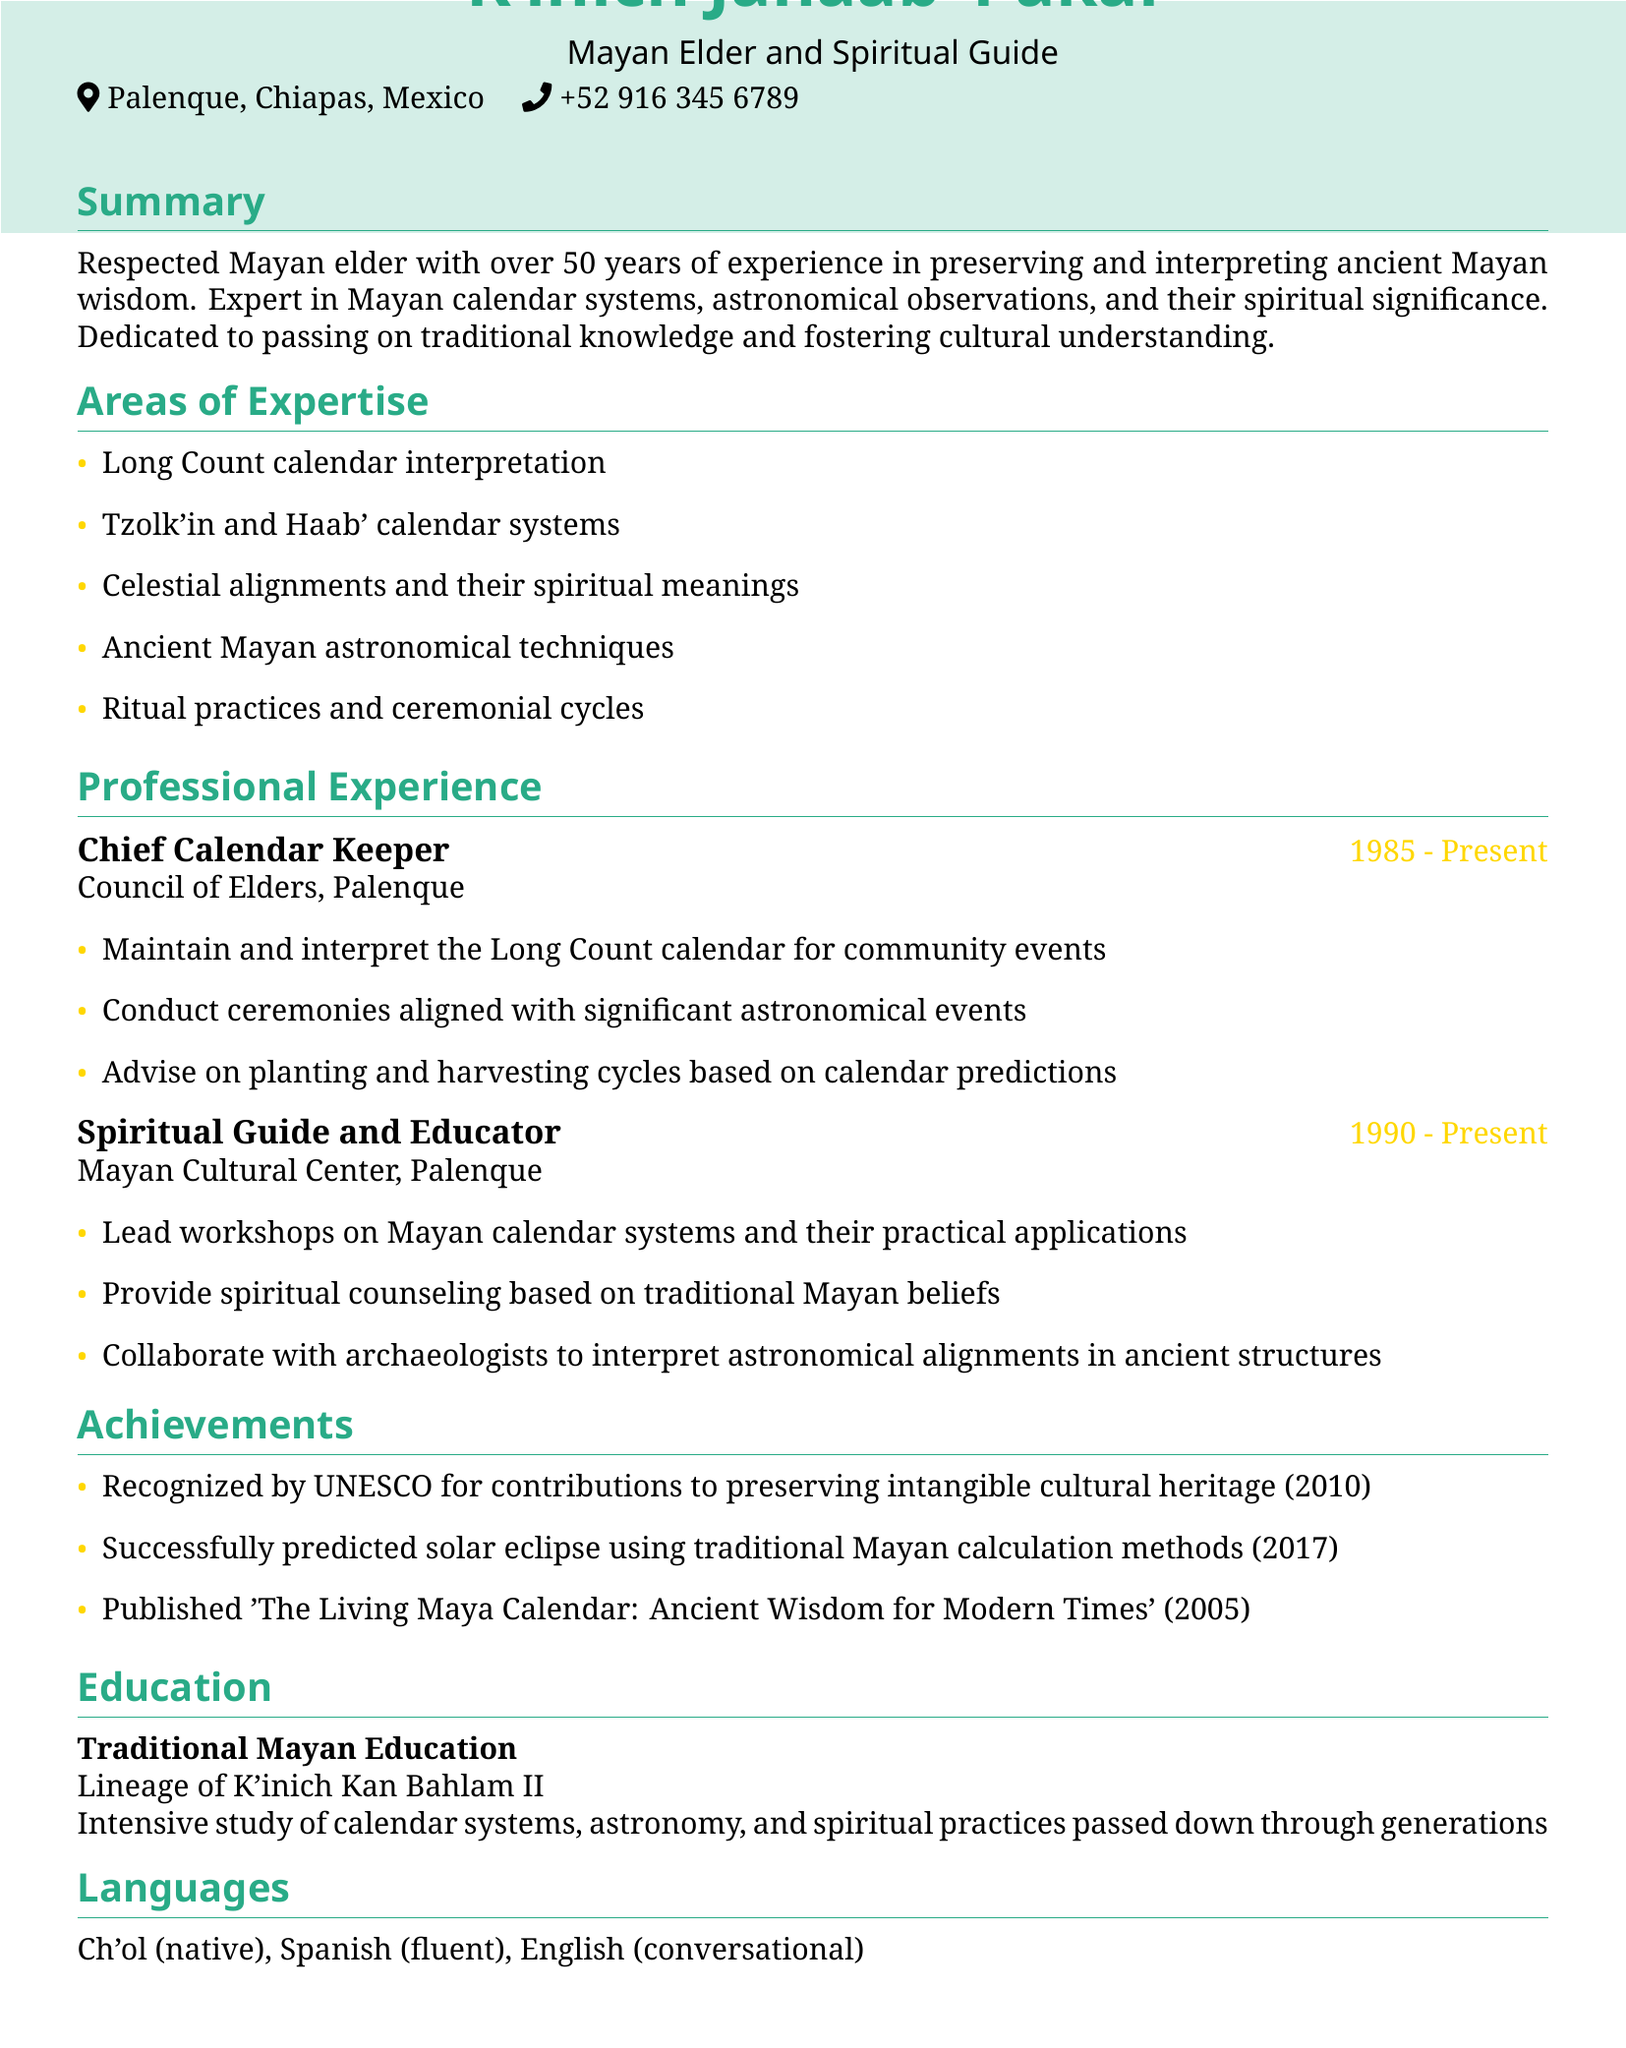what is the name of the individual? The name of the individual is found at the beginning of the document as K'inich Janaab' Pakal.
Answer: K'inich Janaab' Pakal what is the title of K'inich Janaab' Pakal? The title is mentioned in the personal info section, describing his role as a Mayan Elder and Spiritual Guide.
Answer: Mayan Elder and Spiritual Guide how many years of experience does he have? The summary states he has over 50 years of experience in preserving and interpreting ancient Mayan wisdom.
Answer: 50 years which calendar systems is he an expert in? Areas of expertise list several calendar systems, including Long Count, Tzolk'in, and Haab'.
Answer: Long Count, Tzolk'in, Haab' in what year was he recognized by UNESCO? The achievements section specifies that he was recognized by UNESCO in the year 2010.
Answer: 2010 what is his primary language? The languages section identifies Ch'ol as his native language, indicating it as his primary language.
Answer: Ch'ol which organization has he been associated with since 1985? The professional experience section lists the Council of Elders, Palenque as the organization since 1985.
Answer: Council of Elders, Palenque what is the name of the published work authored by him? The achievements section mentions the title of his published work as 'The Living Maya Calendar: Ancient Wisdom for Modern Times'.
Answer: The Living Maya Calendar: Ancient Wisdom for Modern Times 